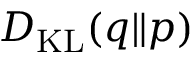Convert formula to latex. <formula><loc_0><loc_0><loc_500><loc_500>D _ { K L } ( q \| p )</formula> 